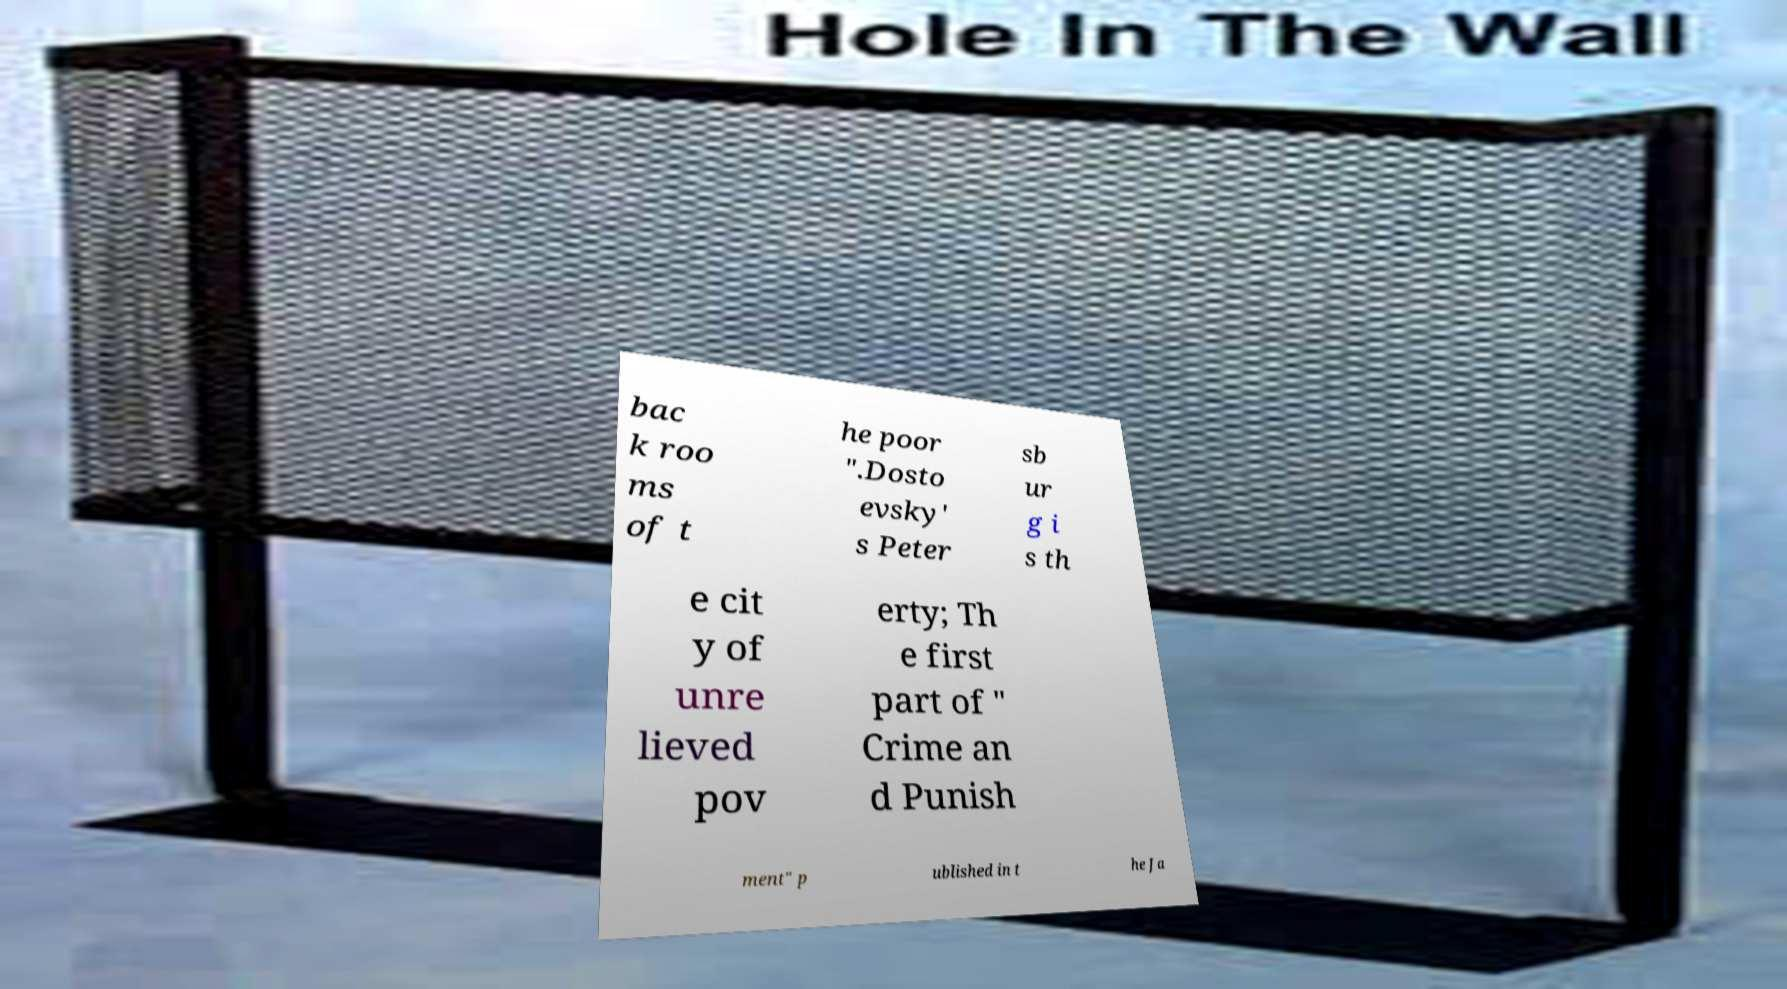Can you accurately transcribe the text from the provided image for me? bac k roo ms of t he poor ".Dosto evsky' s Peter sb ur g i s th e cit y of unre lieved pov erty; Th e first part of " Crime an d Punish ment" p ublished in t he Ja 